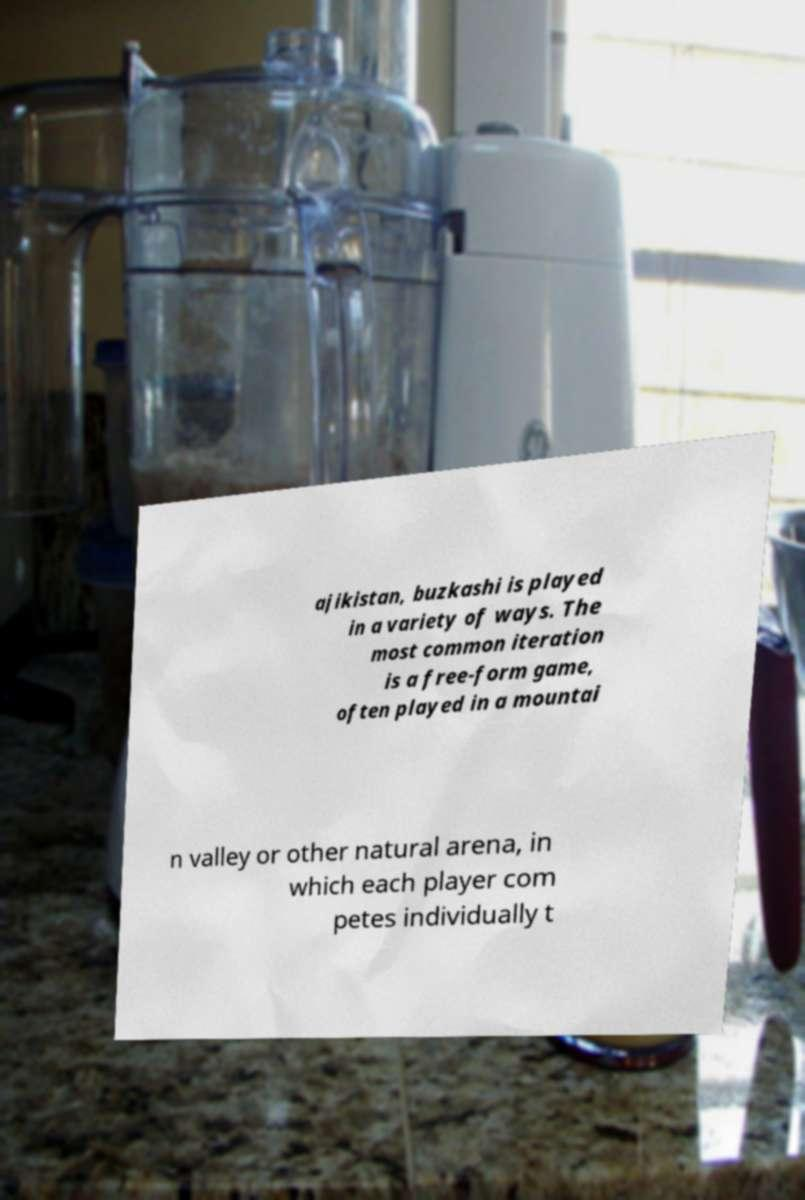I need the written content from this picture converted into text. Can you do that? ajikistan, buzkashi is played in a variety of ways. The most common iteration is a free-form game, often played in a mountai n valley or other natural arena, in which each player com petes individually t 